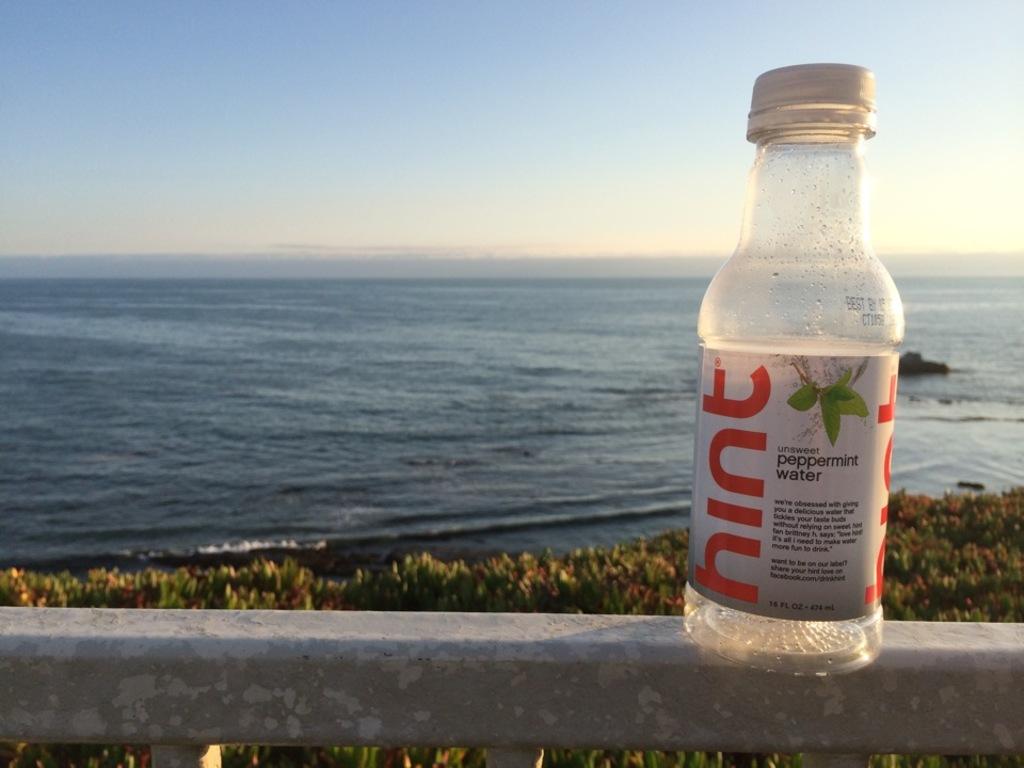What is the flavor of this water?
Your answer should be very brief. Peppermint. How many ounces is the bottle?
Your response must be concise. 16. 